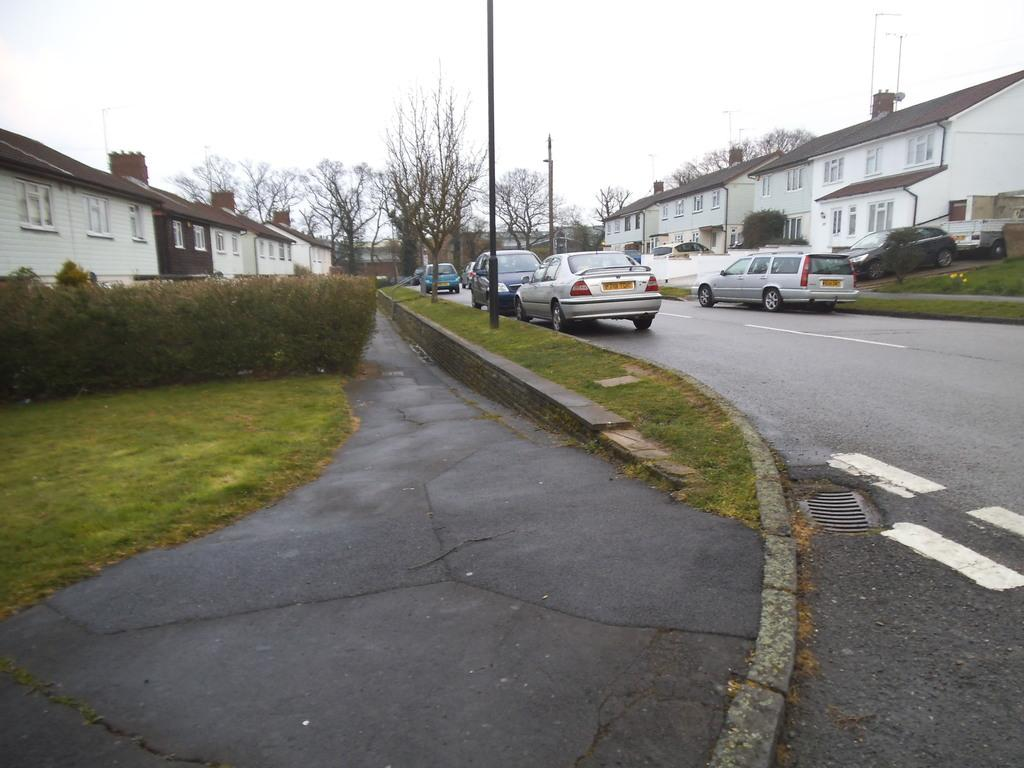What is happening on the road in the image? There are vehicles on the road in the image. What structures can be seen in the image? There are buildings visible in the image. What type of natural elements are present in the image? There are plants and trees in the image. How many poles are in the image? There are two poles in the image. What is visible at the top of the image? The sky is visible at the top of the image. What type of test is being conducted on the writer in the image? There is no writer or test present in the image; it features vehicles on the road, buildings, plants and trees, poles, and the sky. 